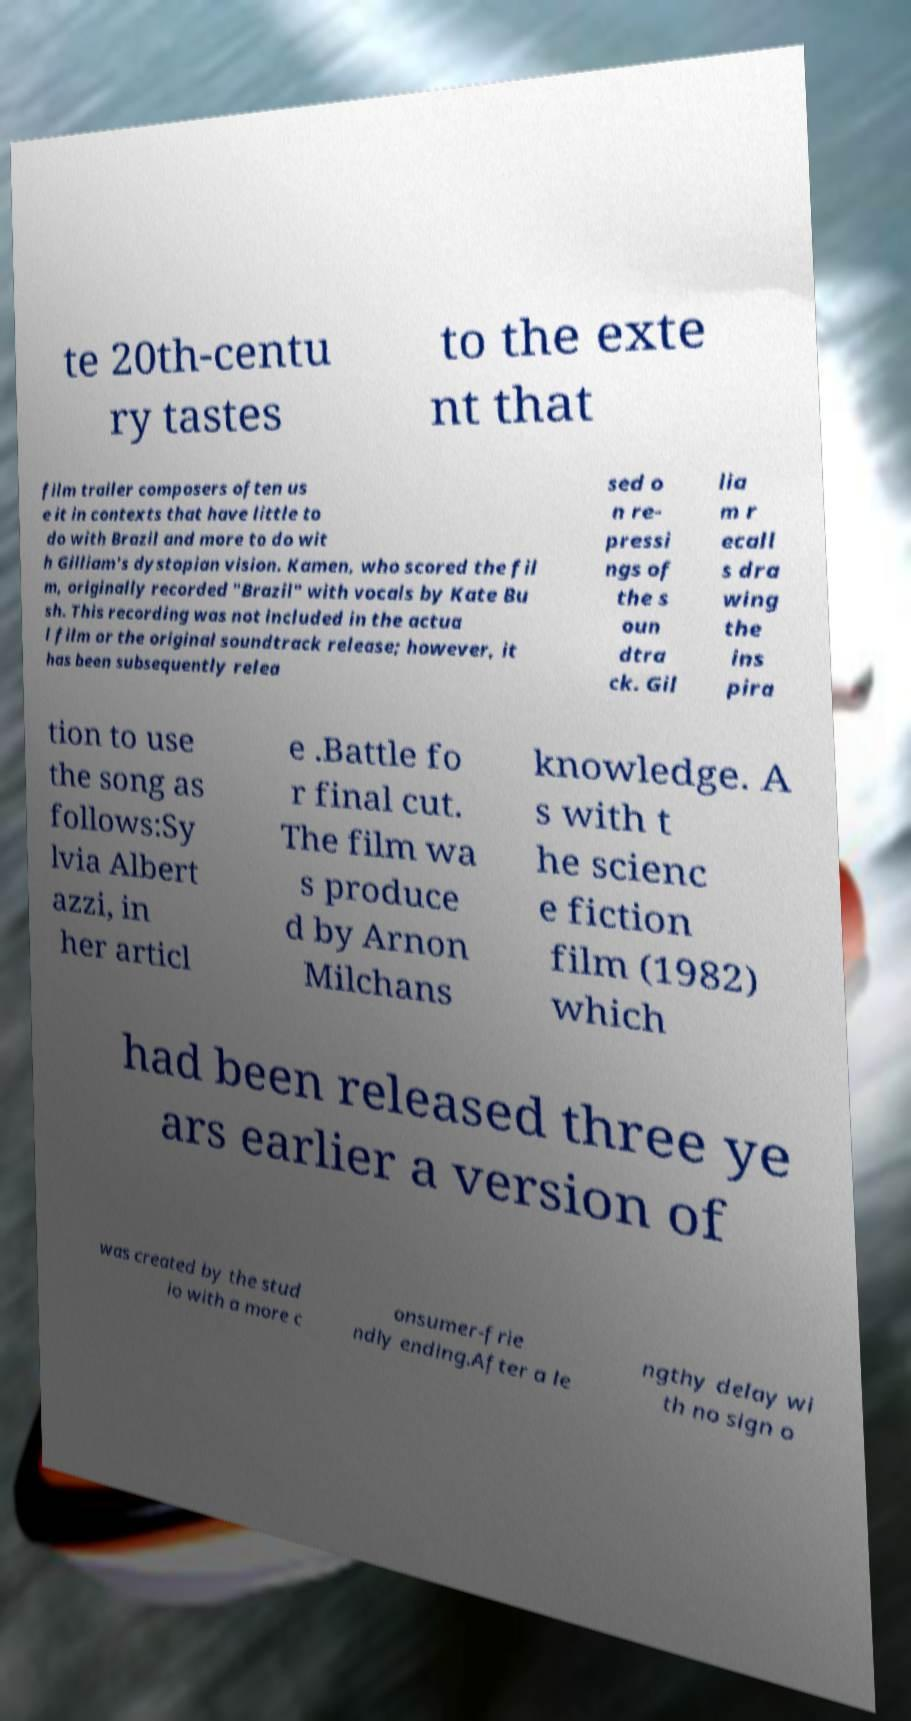What messages or text are displayed in this image? I need them in a readable, typed format. te 20th-centu ry tastes to the exte nt that film trailer composers often us e it in contexts that have little to do with Brazil and more to do wit h Gilliam's dystopian vision. Kamen, who scored the fil m, originally recorded "Brazil" with vocals by Kate Bu sh. This recording was not included in the actua l film or the original soundtrack release; however, it has been subsequently relea sed o n re- pressi ngs of the s oun dtra ck. Gil lia m r ecall s dra wing the ins pira tion to use the song as follows:Sy lvia Albert azzi, in her articl e .Battle fo r final cut. The film wa s produce d by Arnon Milchans knowledge. A s with t he scienc e fiction film (1982) which had been released three ye ars earlier a version of was created by the stud io with a more c onsumer-frie ndly ending.After a le ngthy delay wi th no sign o 